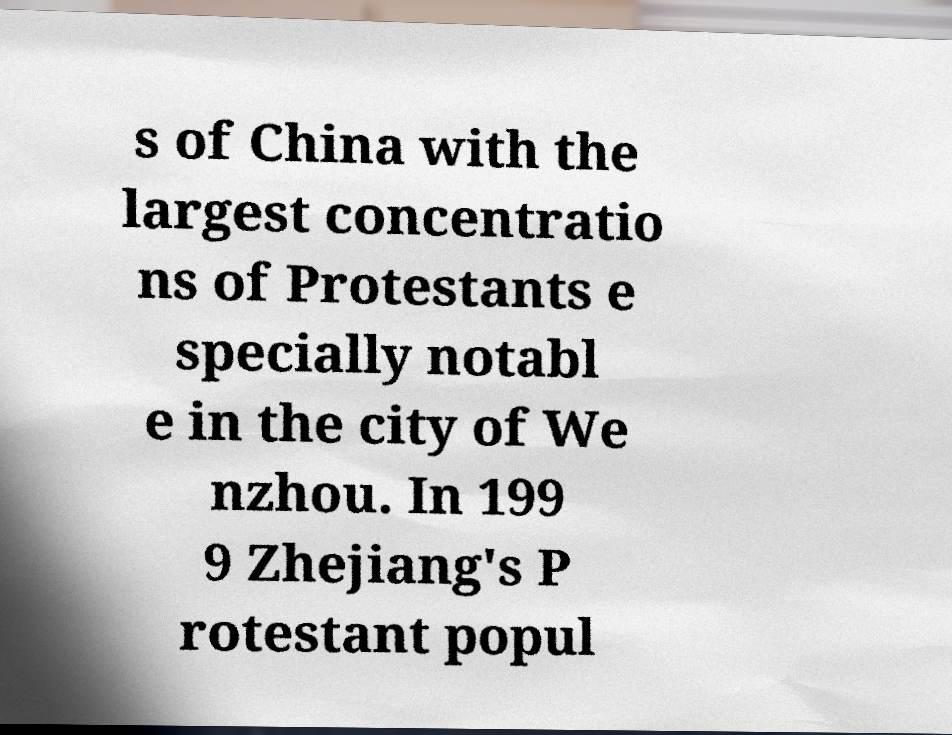Please read and relay the text visible in this image. What does it say? s of China with the largest concentratio ns of Protestants e specially notabl e in the city of We nzhou. In 199 9 Zhejiang's P rotestant popul 